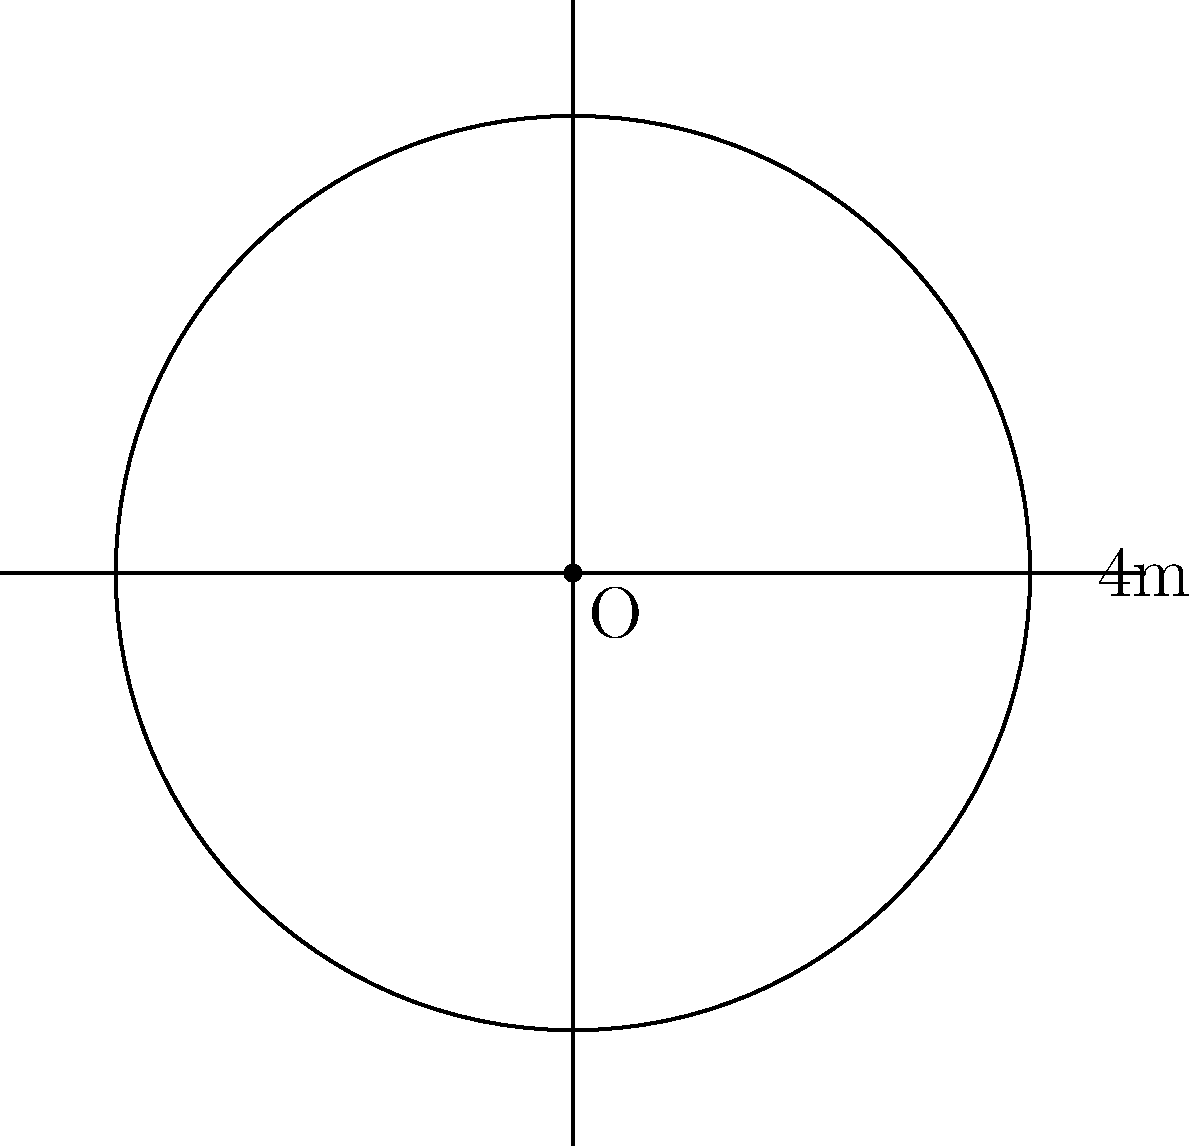A local farmer has installed a spherical water tank on their property to support irrigation. As a law enforcement officer patrolling the area, you've been asked to estimate the tank's capacity for a potential emergency water supply. If the diameter of the tank is 4 meters, what is the total surface area of the tank? Let's approach this step-by-step:

1) The formula for the surface area of a sphere is:
   $$A = 4\pi r^2$$
   where $A$ is the surface area and $r$ is the radius of the sphere.

2) We're given the diameter, which is 4 meters. To find the radius, we divide the diameter by 2:
   $$r = \frac{4}{2} = 2\text{ meters}$$

3) Now we can substitute this into our formula:
   $$A = 4\pi (2)^2$$

4) Simplify:
   $$A = 4\pi (4) = 16\pi$$

5) If we want to calculate the exact value:
   $$A = 16\pi \approx 50.27\text{ square meters}$$

Therefore, the total surface area of the spherical water tank is $16\pi$ or approximately 50.27 square meters.
Answer: $16\pi$ square meters 